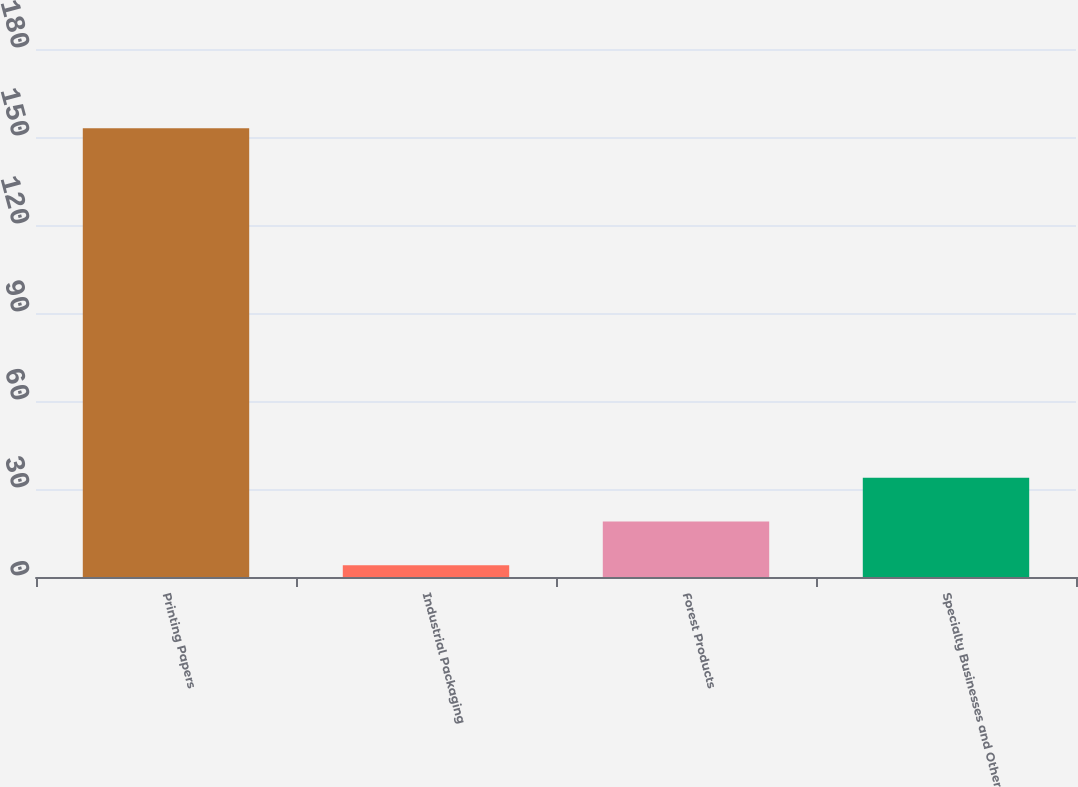Convert chart to OTSL. <chart><loc_0><loc_0><loc_500><loc_500><bar_chart><fcel>Printing Papers<fcel>Industrial Packaging<fcel>Forest Products<fcel>Specialty Businesses and Other<nl><fcel>153<fcel>4<fcel>18.9<fcel>33.8<nl></chart> 